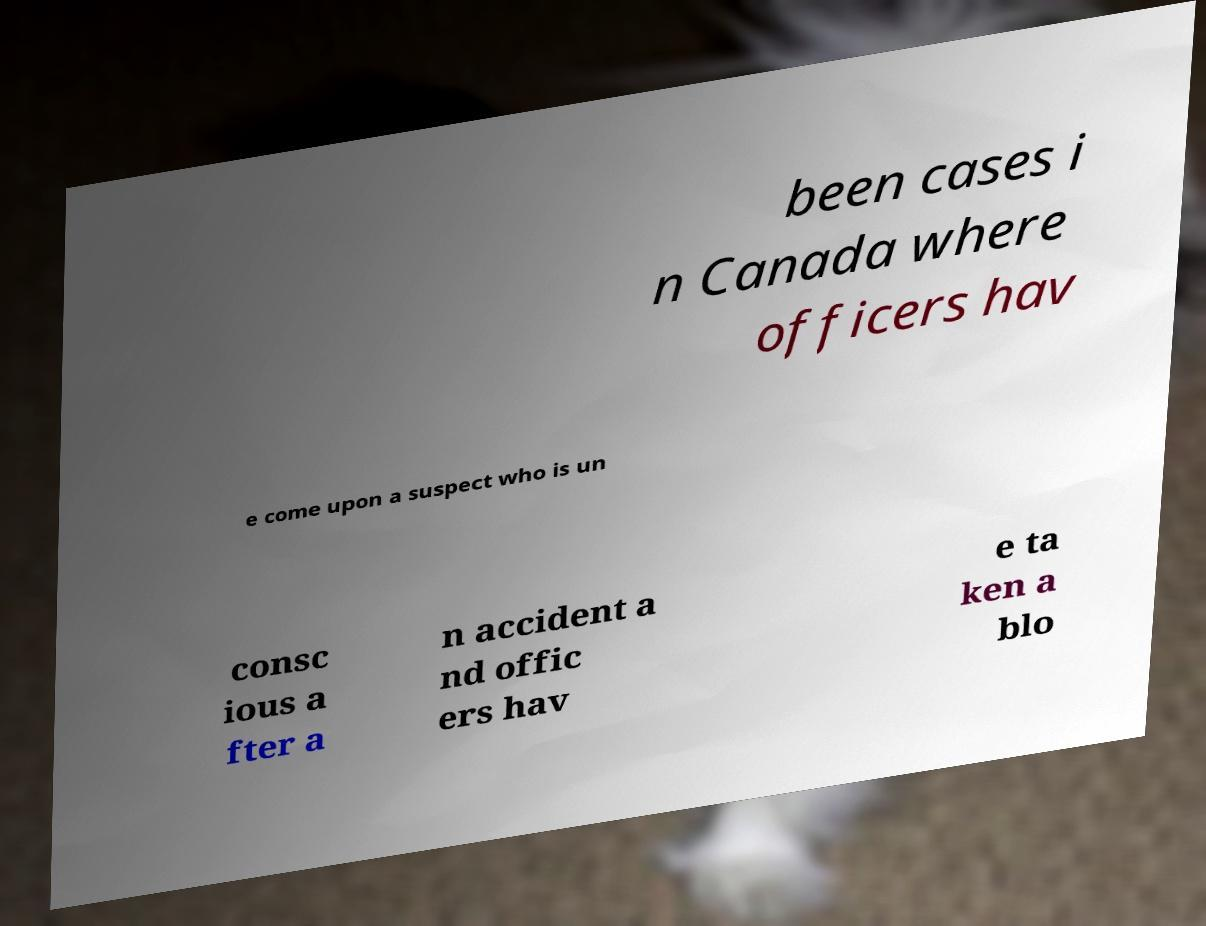Can you read and provide the text displayed in the image?This photo seems to have some interesting text. Can you extract and type it out for me? been cases i n Canada where officers hav e come upon a suspect who is un consc ious a fter a n accident a nd offic ers hav e ta ken a blo 